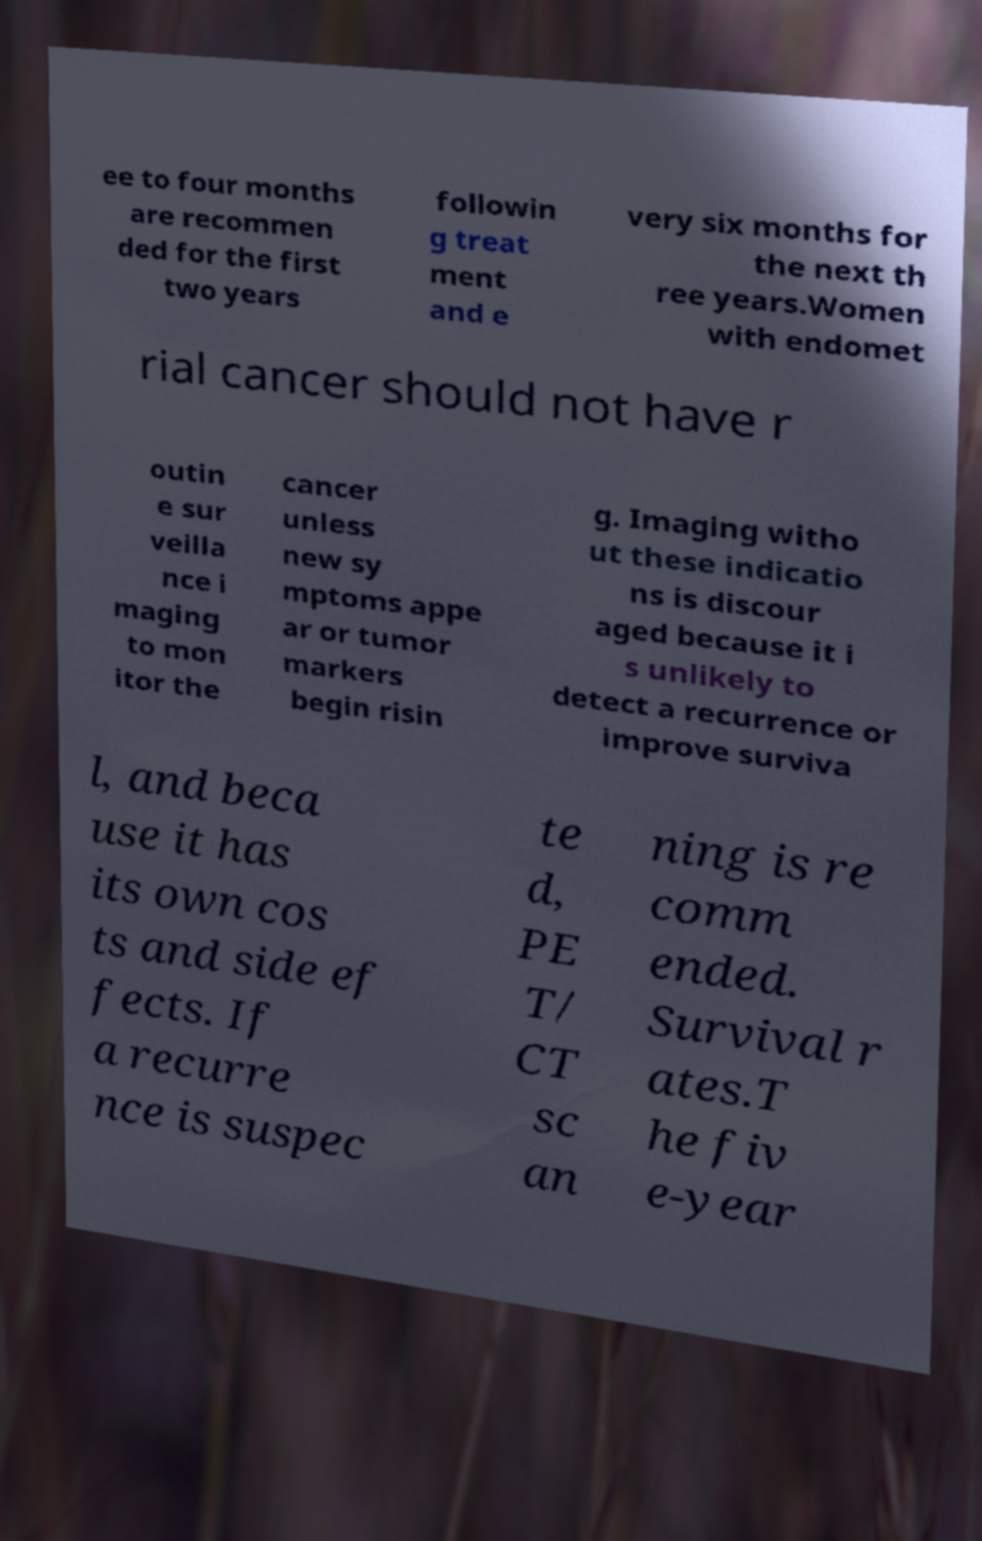Please read and relay the text visible in this image. What does it say? ee to four months are recommen ded for the first two years followin g treat ment and e very six months for the next th ree years.Women with endomet rial cancer should not have r outin e sur veilla nce i maging to mon itor the cancer unless new sy mptoms appe ar or tumor markers begin risin g. Imaging witho ut these indicatio ns is discour aged because it i s unlikely to detect a recurrence or improve surviva l, and beca use it has its own cos ts and side ef fects. If a recurre nce is suspec te d, PE T/ CT sc an ning is re comm ended. Survival r ates.T he fiv e-year 